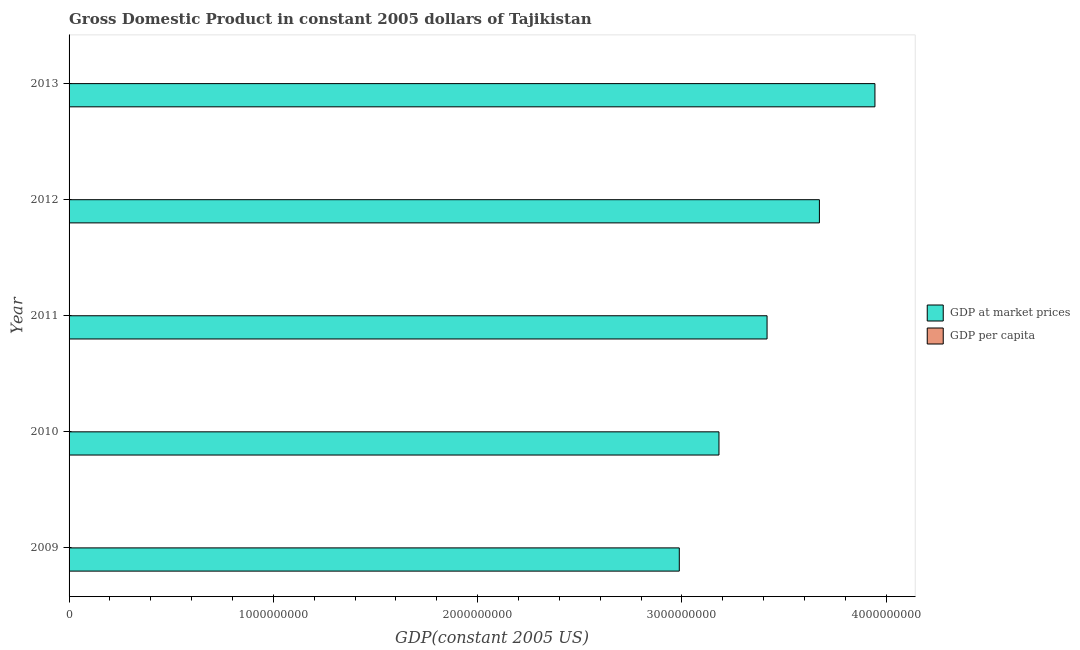How many groups of bars are there?
Make the answer very short. 5. Are the number of bars per tick equal to the number of legend labels?
Offer a terse response. Yes. Are the number of bars on each tick of the Y-axis equal?
Your answer should be very brief. Yes. What is the label of the 5th group of bars from the top?
Provide a succinct answer. 2009. In how many cases, is the number of bars for a given year not equal to the number of legend labels?
Keep it short and to the point. 0. What is the gdp at market prices in 2012?
Your answer should be very brief. 3.67e+09. Across all years, what is the maximum gdp at market prices?
Keep it short and to the point. 3.94e+09. Across all years, what is the minimum gdp at market prices?
Your response must be concise. 2.99e+09. What is the total gdp per capita in the graph?
Give a very brief answer. 2212.61. What is the difference between the gdp per capita in 2012 and that in 2013?
Provide a succinct answer. -23.18. What is the difference between the gdp per capita in 2011 and the gdp at market prices in 2010?
Your answer should be very brief. -3.18e+09. What is the average gdp per capita per year?
Your answer should be compact. 442.52. In the year 2011, what is the difference between the gdp per capita and gdp at market prices?
Provide a short and direct response. -3.42e+09. In how many years, is the gdp per capita greater than 1800000000 US$?
Give a very brief answer. 0. What is the ratio of the gdp at market prices in 2009 to that in 2012?
Offer a terse response. 0.81. Is the difference between the gdp per capita in 2009 and 2012 greater than the difference between the gdp at market prices in 2009 and 2012?
Give a very brief answer. Yes. What is the difference between the highest and the second highest gdp per capita?
Your answer should be compact. 23.18. What is the difference between the highest and the lowest gdp at market prices?
Your answer should be very brief. 9.58e+08. In how many years, is the gdp at market prices greater than the average gdp at market prices taken over all years?
Offer a very short reply. 2. What does the 2nd bar from the top in 2013 represents?
Your answer should be very brief. GDP at market prices. What does the 2nd bar from the bottom in 2010 represents?
Give a very brief answer. GDP per capita. How many bars are there?
Keep it short and to the point. 10. Are all the bars in the graph horizontal?
Offer a terse response. Yes. What is the difference between two consecutive major ticks on the X-axis?
Provide a succinct answer. 1.00e+09. Are the values on the major ticks of X-axis written in scientific E-notation?
Give a very brief answer. No. Does the graph contain grids?
Provide a succinct answer. No. Where does the legend appear in the graph?
Your response must be concise. Center right. What is the title of the graph?
Keep it short and to the point. Gross Domestic Product in constant 2005 dollars of Tajikistan. Does "Arms exports" appear as one of the legend labels in the graph?
Offer a terse response. No. What is the label or title of the X-axis?
Keep it short and to the point. GDP(constant 2005 US). What is the label or title of the Y-axis?
Provide a short and direct response. Year. What is the GDP(constant 2005 US) in GDP at market prices in 2009?
Offer a very short reply. 2.99e+09. What is the GDP(constant 2005 US) in GDP per capita in 2009?
Offer a terse response. 402.87. What is the GDP(constant 2005 US) of GDP at market prices in 2010?
Your answer should be very brief. 3.18e+09. What is the GDP(constant 2005 US) of GDP per capita in 2010?
Make the answer very short. 419.62. What is the GDP(constant 2005 US) in GDP at market prices in 2011?
Make the answer very short. 3.42e+09. What is the GDP(constant 2005 US) of GDP per capita in 2011?
Offer a terse response. 440.66. What is the GDP(constant 2005 US) in GDP at market prices in 2012?
Offer a very short reply. 3.67e+09. What is the GDP(constant 2005 US) of GDP per capita in 2012?
Your response must be concise. 463.14. What is the GDP(constant 2005 US) of GDP at market prices in 2013?
Provide a succinct answer. 3.94e+09. What is the GDP(constant 2005 US) of GDP per capita in 2013?
Make the answer very short. 486.32. Across all years, what is the maximum GDP(constant 2005 US) in GDP at market prices?
Ensure brevity in your answer.  3.94e+09. Across all years, what is the maximum GDP(constant 2005 US) in GDP per capita?
Offer a very short reply. 486.32. Across all years, what is the minimum GDP(constant 2005 US) in GDP at market prices?
Ensure brevity in your answer.  2.99e+09. Across all years, what is the minimum GDP(constant 2005 US) of GDP per capita?
Offer a very short reply. 402.87. What is the total GDP(constant 2005 US) of GDP at market prices in the graph?
Keep it short and to the point. 1.72e+1. What is the total GDP(constant 2005 US) in GDP per capita in the graph?
Offer a terse response. 2212.61. What is the difference between the GDP(constant 2005 US) in GDP at market prices in 2009 and that in 2010?
Give a very brief answer. -1.94e+08. What is the difference between the GDP(constant 2005 US) of GDP per capita in 2009 and that in 2010?
Provide a succinct answer. -16.75. What is the difference between the GDP(constant 2005 US) of GDP at market prices in 2009 and that in 2011?
Offer a terse response. -4.30e+08. What is the difference between the GDP(constant 2005 US) in GDP per capita in 2009 and that in 2011?
Your response must be concise. -37.79. What is the difference between the GDP(constant 2005 US) in GDP at market prices in 2009 and that in 2012?
Give a very brief answer. -6.86e+08. What is the difference between the GDP(constant 2005 US) of GDP per capita in 2009 and that in 2012?
Offer a terse response. -60.27. What is the difference between the GDP(constant 2005 US) of GDP at market prices in 2009 and that in 2013?
Ensure brevity in your answer.  -9.58e+08. What is the difference between the GDP(constant 2005 US) of GDP per capita in 2009 and that in 2013?
Provide a succinct answer. -83.45. What is the difference between the GDP(constant 2005 US) of GDP at market prices in 2010 and that in 2011?
Make the answer very short. -2.35e+08. What is the difference between the GDP(constant 2005 US) in GDP per capita in 2010 and that in 2011?
Your answer should be compact. -21.04. What is the difference between the GDP(constant 2005 US) of GDP at market prices in 2010 and that in 2012?
Ensure brevity in your answer.  -4.92e+08. What is the difference between the GDP(constant 2005 US) of GDP per capita in 2010 and that in 2012?
Your answer should be compact. -43.52. What is the difference between the GDP(constant 2005 US) in GDP at market prices in 2010 and that in 2013?
Give a very brief answer. -7.64e+08. What is the difference between the GDP(constant 2005 US) in GDP per capita in 2010 and that in 2013?
Give a very brief answer. -66.69. What is the difference between the GDP(constant 2005 US) in GDP at market prices in 2011 and that in 2012?
Keep it short and to the point. -2.56e+08. What is the difference between the GDP(constant 2005 US) of GDP per capita in 2011 and that in 2012?
Provide a succinct answer. -22.48. What is the difference between the GDP(constant 2005 US) of GDP at market prices in 2011 and that in 2013?
Offer a terse response. -5.28e+08. What is the difference between the GDP(constant 2005 US) in GDP per capita in 2011 and that in 2013?
Your response must be concise. -45.65. What is the difference between the GDP(constant 2005 US) in GDP at market prices in 2012 and that in 2013?
Offer a terse response. -2.72e+08. What is the difference between the GDP(constant 2005 US) of GDP per capita in 2012 and that in 2013?
Ensure brevity in your answer.  -23.18. What is the difference between the GDP(constant 2005 US) in GDP at market prices in 2009 and the GDP(constant 2005 US) in GDP per capita in 2010?
Provide a succinct answer. 2.99e+09. What is the difference between the GDP(constant 2005 US) of GDP at market prices in 2009 and the GDP(constant 2005 US) of GDP per capita in 2011?
Your answer should be compact. 2.99e+09. What is the difference between the GDP(constant 2005 US) in GDP at market prices in 2009 and the GDP(constant 2005 US) in GDP per capita in 2012?
Make the answer very short. 2.99e+09. What is the difference between the GDP(constant 2005 US) of GDP at market prices in 2009 and the GDP(constant 2005 US) of GDP per capita in 2013?
Your response must be concise. 2.99e+09. What is the difference between the GDP(constant 2005 US) in GDP at market prices in 2010 and the GDP(constant 2005 US) in GDP per capita in 2011?
Your answer should be very brief. 3.18e+09. What is the difference between the GDP(constant 2005 US) of GDP at market prices in 2010 and the GDP(constant 2005 US) of GDP per capita in 2012?
Your answer should be very brief. 3.18e+09. What is the difference between the GDP(constant 2005 US) in GDP at market prices in 2010 and the GDP(constant 2005 US) in GDP per capita in 2013?
Offer a very short reply. 3.18e+09. What is the difference between the GDP(constant 2005 US) of GDP at market prices in 2011 and the GDP(constant 2005 US) of GDP per capita in 2012?
Provide a succinct answer. 3.42e+09. What is the difference between the GDP(constant 2005 US) of GDP at market prices in 2011 and the GDP(constant 2005 US) of GDP per capita in 2013?
Offer a terse response. 3.42e+09. What is the difference between the GDP(constant 2005 US) of GDP at market prices in 2012 and the GDP(constant 2005 US) of GDP per capita in 2013?
Offer a very short reply. 3.67e+09. What is the average GDP(constant 2005 US) of GDP at market prices per year?
Keep it short and to the point. 3.44e+09. What is the average GDP(constant 2005 US) of GDP per capita per year?
Keep it short and to the point. 442.52. In the year 2009, what is the difference between the GDP(constant 2005 US) in GDP at market prices and GDP(constant 2005 US) in GDP per capita?
Keep it short and to the point. 2.99e+09. In the year 2010, what is the difference between the GDP(constant 2005 US) in GDP at market prices and GDP(constant 2005 US) in GDP per capita?
Make the answer very short. 3.18e+09. In the year 2011, what is the difference between the GDP(constant 2005 US) of GDP at market prices and GDP(constant 2005 US) of GDP per capita?
Keep it short and to the point. 3.42e+09. In the year 2012, what is the difference between the GDP(constant 2005 US) of GDP at market prices and GDP(constant 2005 US) of GDP per capita?
Offer a very short reply. 3.67e+09. In the year 2013, what is the difference between the GDP(constant 2005 US) of GDP at market prices and GDP(constant 2005 US) of GDP per capita?
Give a very brief answer. 3.94e+09. What is the ratio of the GDP(constant 2005 US) in GDP at market prices in 2009 to that in 2010?
Give a very brief answer. 0.94. What is the ratio of the GDP(constant 2005 US) in GDP per capita in 2009 to that in 2010?
Give a very brief answer. 0.96. What is the ratio of the GDP(constant 2005 US) of GDP at market prices in 2009 to that in 2011?
Your answer should be very brief. 0.87. What is the ratio of the GDP(constant 2005 US) of GDP per capita in 2009 to that in 2011?
Provide a short and direct response. 0.91. What is the ratio of the GDP(constant 2005 US) of GDP at market prices in 2009 to that in 2012?
Your response must be concise. 0.81. What is the ratio of the GDP(constant 2005 US) in GDP per capita in 2009 to that in 2012?
Your response must be concise. 0.87. What is the ratio of the GDP(constant 2005 US) of GDP at market prices in 2009 to that in 2013?
Offer a terse response. 0.76. What is the ratio of the GDP(constant 2005 US) of GDP per capita in 2009 to that in 2013?
Your response must be concise. 0.83. What is the ratio of the GDP(constant 2005 US) in GDP at market prices in 2010 to that in 2011?
Provide a succinct answer. 0.93. What is the ratio of the GDP(constant 2005 US) in GDP per capita in 2010 to that in 2011?
Make the answer very short. 0.95. What is the ratio of the GDP(constant 2005 US) of GDP at market prices in 2010 to that in 2012?
Offer a very short reply. 0.87. What is the ratio of the GDP(constant 2005 US) in GDP per capita in 2010 to that in 2012?
Your answer should be compact. 0.91. What is the ratio of the GDP(constant 2005 US) in GDP at market prices in 2010 to that in 2013?
Your answer should be very brief. 0.81. What is the ratio of the GDP(constant 2005 US) of GDP per capita in 2010 to that in 2013?
Provide a short and direct response. 0.86. What is the ratio of the GDP(constant 2005 US) of GDP at market prices in 2011 to that in 2012?
Provide a succinct answer. 0.93. What is the ratio of the GDP(constant 2005 US) in GDP per capita in 2011 to that in 2012?
Keep it short and to the point. 0.95. What is the ratio of the GDP(constant 2005 US) of GDP at market prices in 2011 to that in 2013?
Keep it short and to the point. 0.87. What is the ratio of the GDP(constant 2005 US) of GDP per capita in 2011 to that in 2013?
Your response must be concise. 0.91. What is the ratio of the GDP(constant 2005 US) of GDP at market prices in 2012 to that in 2013?
Keep it short and to the point. 0.93. What is the ratio of the GDP(constant 2005 US) in GDP per capita in 2012 to that in 2013?
Give a very brief answer. 0.95. What is the difference between the highest and the second highest GDP(constant 2005 US) of GDP at market prices?
Offer a very short reply. 2.72e+08. What is the difference between the highest and the second highest GDP(constant 2005 US) in GDP per capita?
Make the answer very short. 23.18. What is the difference between the highest and the lowest GDP(constant 2005 US) in GDP at market prices?
Make the answer very short. 9.58e+08. What is the difference between the highest and the lowest GDP(constant 2005 US) in GDP per capita?
Provide a short and direct response. 83.45. 